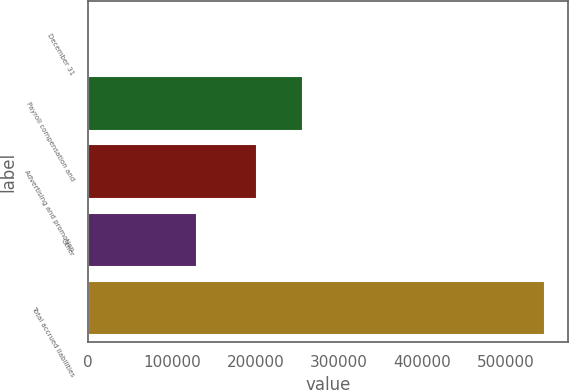<chart> <loc_0><loc_0><loc_500><loc_500><bar_chart><fcel>December 31<fcel>Payroll compensation and<fcel>Advertising and promotion<fcel>Other<fcel>Total accrued liabilities<nl><fcel>2009<fcel>256992<fcel>202547<fcel>130200<fcel>546462<nl></chart> 